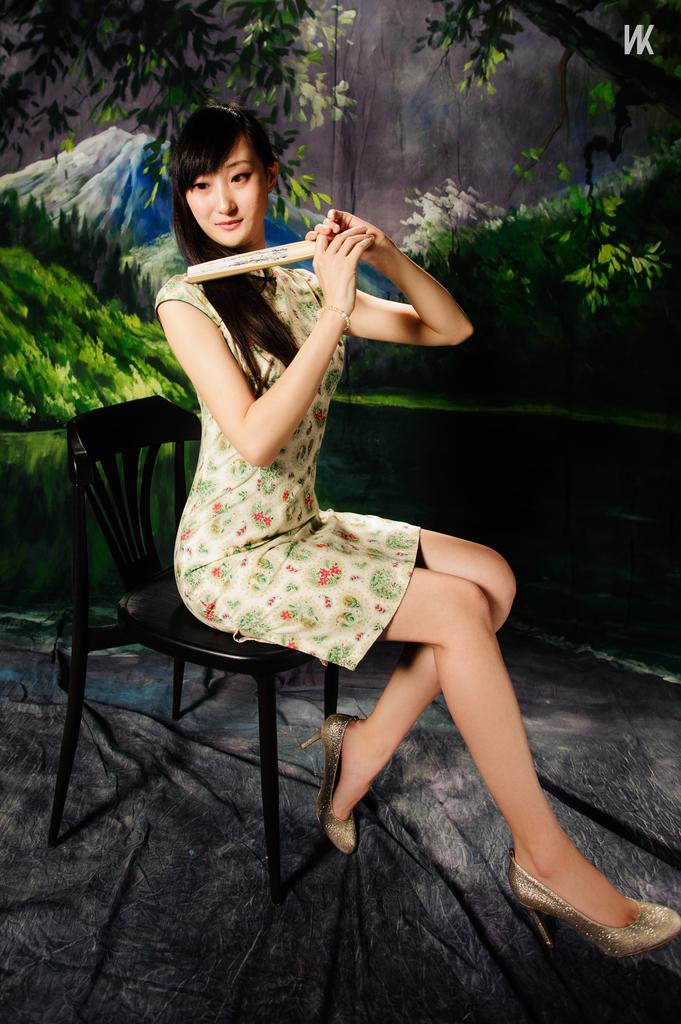Could you give a brief overview of what you see in this image? In this image I can see a woman sitting on a chair. In the background I can see trees mountains. 